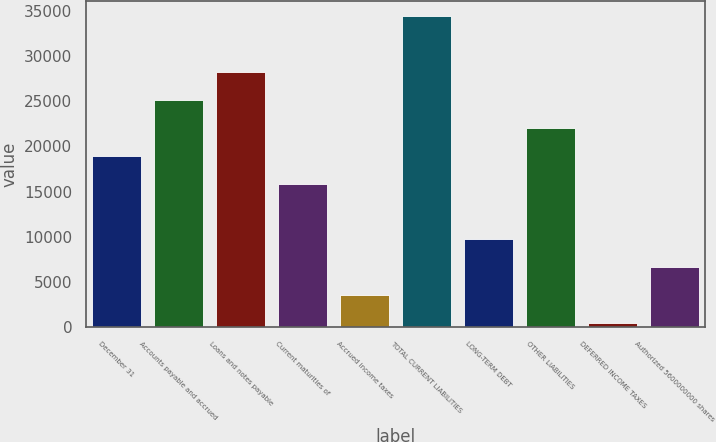Convert chart. <chart><loc_0><loc_0><loc_500><loc_500><bar_chart><fcel>December 31<fcel>Accounts payable and accrued<fcel>Loans and notes payable<fcel>Current maturities of<fcel>Accrued income taxes<fcel>TOTAL CURRENT LIABILITIES<fcel>LONG-TERM DEBT<fcel>OTHER LIABILITIES<fcel>DEFERRED INCOME TAXES<fcel>Authorized 5600000000 shares<nl><fcel>18976.2<fcel>25151.6<fcel>28239.3<fcel>15888.5<fcel>3537.7<fcel>34414.7<fcel>9713.1<fcel>22063.9<fcel>450<fcel>6625.4<nl></chart> 